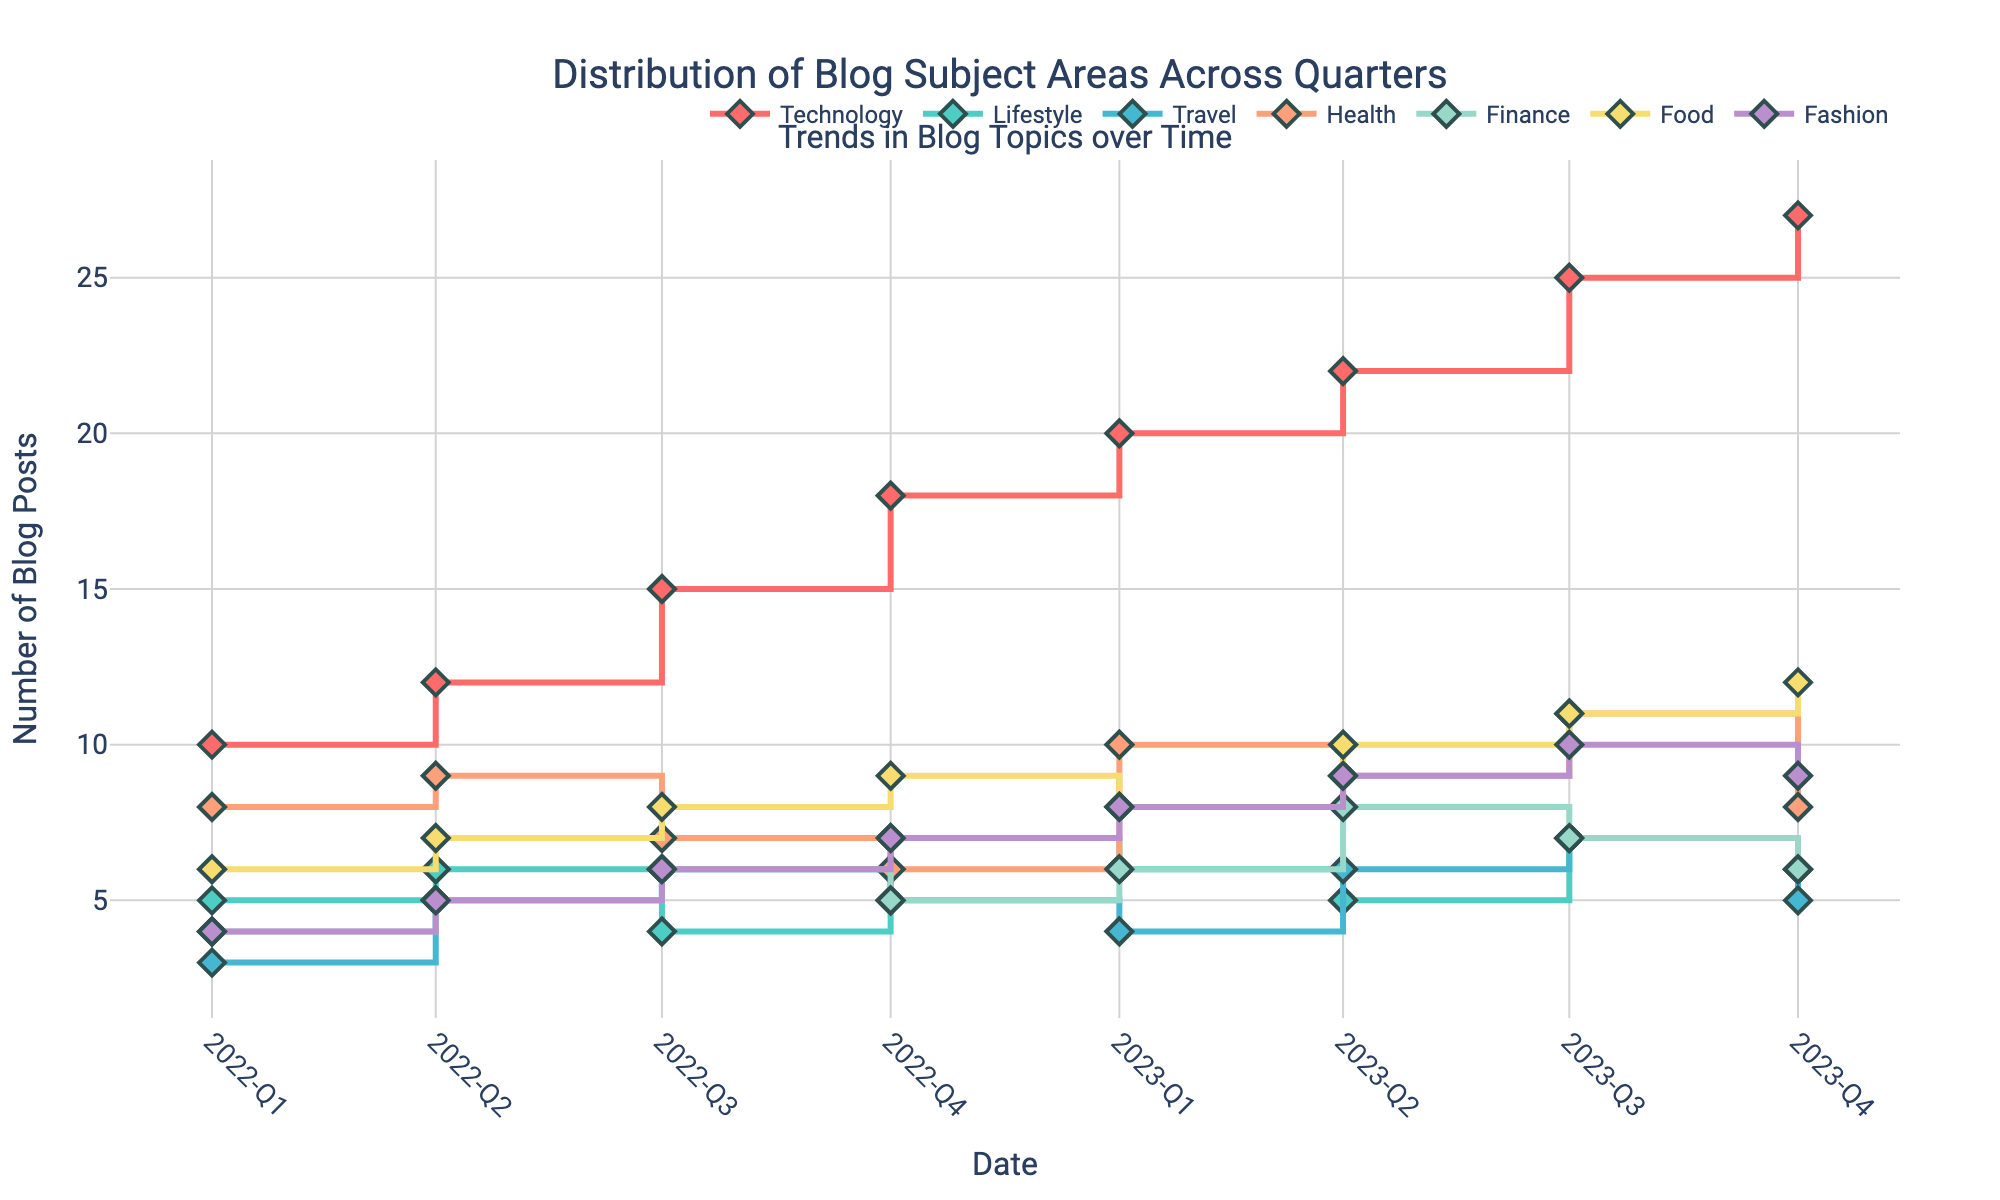Which blog topic category has the highest number of posts in 2023-Q3? By examining the plot, identify the y-value for each blog topic category in 2023-Q3 and find the highest.
Answer: Technology In which quarter did the Finance blog posts peak? Check each quarter's data point for the Finance category and determine the one with the highest y-value.
Answer: 2023-Q2 How many blog posts were written about Travel in 2022-Q3? Identify the y-value for the Travel blog posts in the 2022-Q3 time point on the plot.
Answer: 6 What is the overall trend for Technology blog posts over the given quarters? Observe the line representing Technology from 2022-Q1 to 2023-Q4 to determine if it is increasing, decreasing, or stable.
Answer: Increasing Comparing 2023-Q1 and 2023-Q3, how did the number of Health blog posts change? Calculate the difference in the y-values for Health between these two quarters.
Answer: +1 Which quarter saw the maximum number of Food blog posts and how many were there? Identify the peak y-value for Food and note the corresponding quarter.
Answer: 2023-Q4, 12 What is the average number of blog posts for Fashion from 2022-Q1 to 2022-Q4? Sum the y-values of the Fashion blog posts from 2022-Q1 to 2022-Q4 and then divide by the number of quarters (4).
Answer: (4+5+6+7)/4 = 5.5 Which category had the least variation in blog post numbers throughout the observed quarters? Evaluate the lines for each category and determine which one has the smallest range of y-values (max - min).
Answer: Lifestyle How did the number of Lifestyle blog posts change between 2022-Q1 and 2023-Q4? Calculate the difference in the y-values for Lifestyle between these two quarters.
Answer: +1 Is there any quarter where the number of Travel blog posts is equal to the number of Health blog posts? If yes, which quarter? Compare the y-values of Travel and Health for each quarter to see if they are equal.
Answer: 2022-Q4 